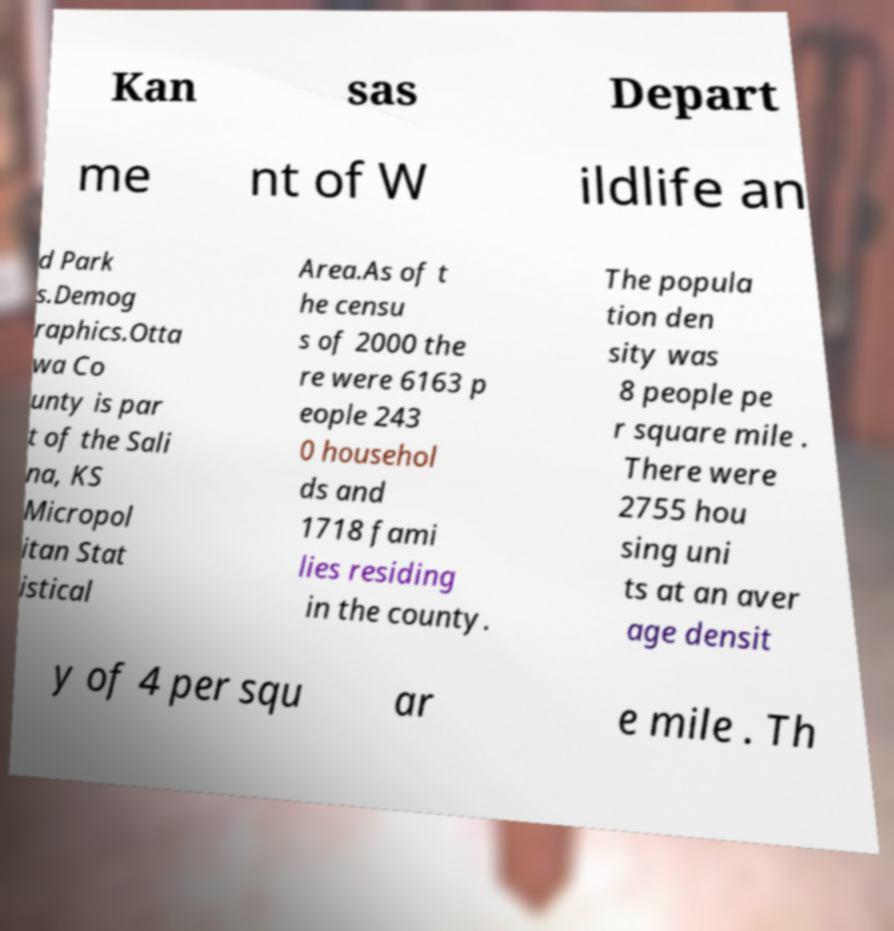Please read and relay the text visible in this image. What does it say? Kan sas Depart me nt of W ildlife an d Park s.Demog raphics.Otta wa Co unty is par t of the Sali na, KS Micropol itan Stat istical Area.As of t he censu s of 2000 the re were 6163 p eople 243 0 househol ds and 1718 fami lies residing in the county. The popula tion den sity was 8 people pe r square mile . There were 2755 hou sing uni ts at an aver age densit y of 4 per squ ar e mile . Th 